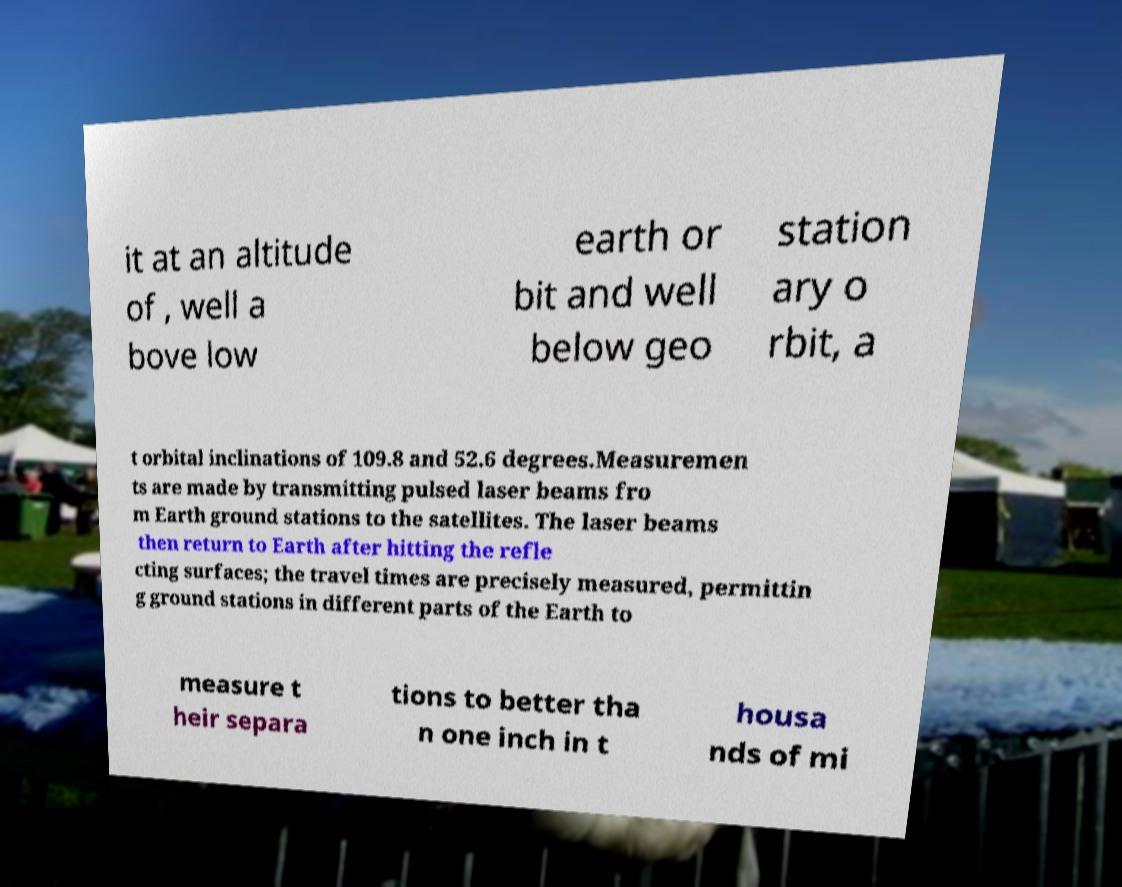Please read and relay the text visible in this image. What does it say? it at an altitude of , well a bove low earth or bit and well below geo station ary o rbit, a t orbital inclinations of 109.8 and 52.6 degrees.Measuremen ts are made by transmitting pulsed laser beams fro m Earth ground stations to the satellites. The laser beams then return to Earth after hitting the refle cting surfaces; the travel times are precisely measured, permittin g ground stations in different parts of the Earth to measure t heir separa tions to better tha n one inch in t housa nds of mi 